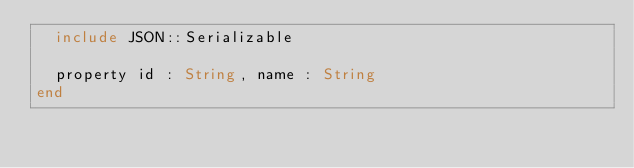<code> <loc_0><loc_0><loc_500><loc_500><_Crystal_>  include JSON::Serializable

  property id : String, name : String
end
</code> 